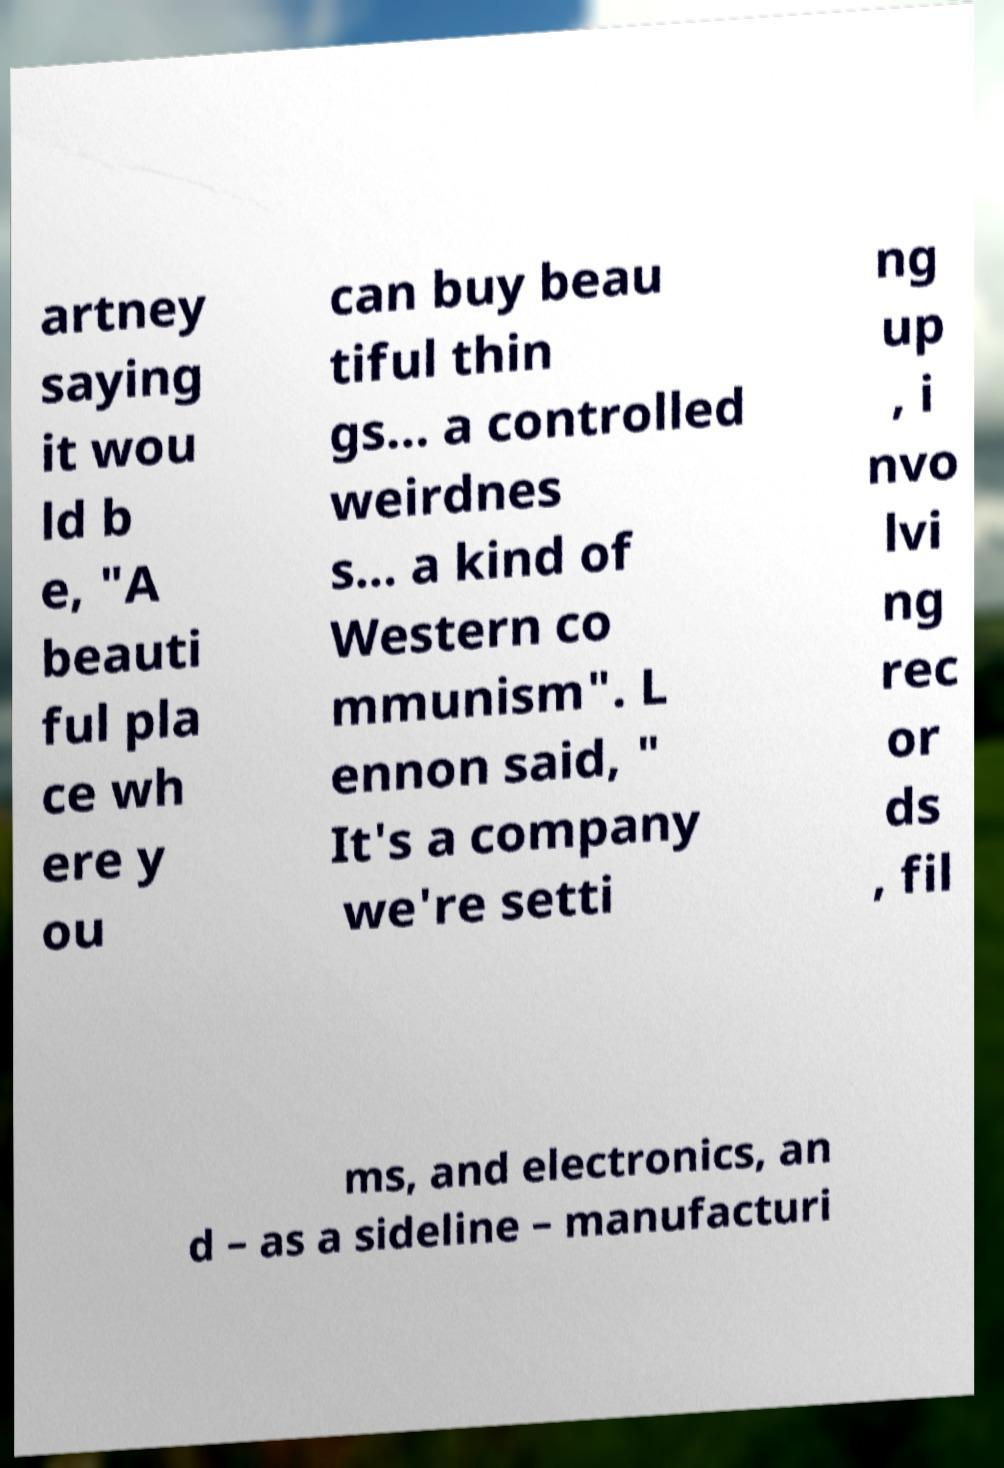There's text embedded in this image that I need extracted. Can you transcribe it verbatim? artney saying it wou ld b e, "A beauti ful pla ce wh ere y ou can buy beau tiful thin gs… a controlled weirdnes s… a kind of Western co mmunism". L ennon said, " It's a company we're setti ng up , i nvo lvi ng rec or ds , fil ms, and electronics, an d – as a sideline – manufacturi 